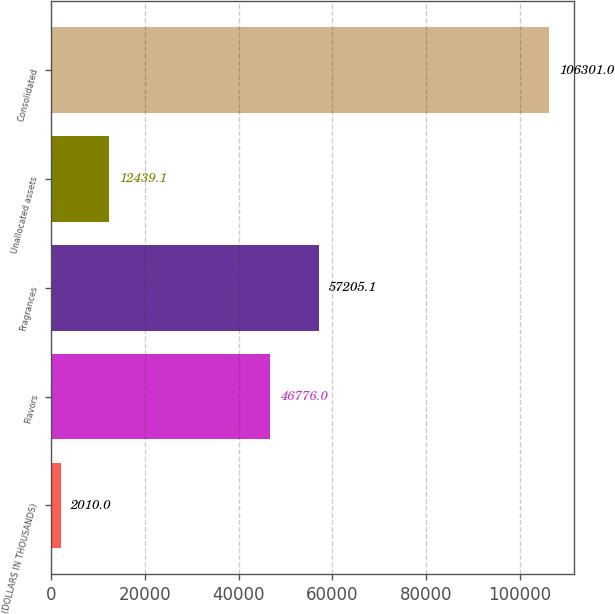<chart> <loc_0><loc_0><loc_500><loc_500><bar_chart><fcel>(DOLLARS IN THOUSANDS)<fcel>Flavors<fcel>Fragrances<fcel>Unallocated assets<fcel>Consolidated<nl><fcel>2010<fcel>46776<fcel>57205.1<fcel>12439.1<fcel>106301<nl></chart> 